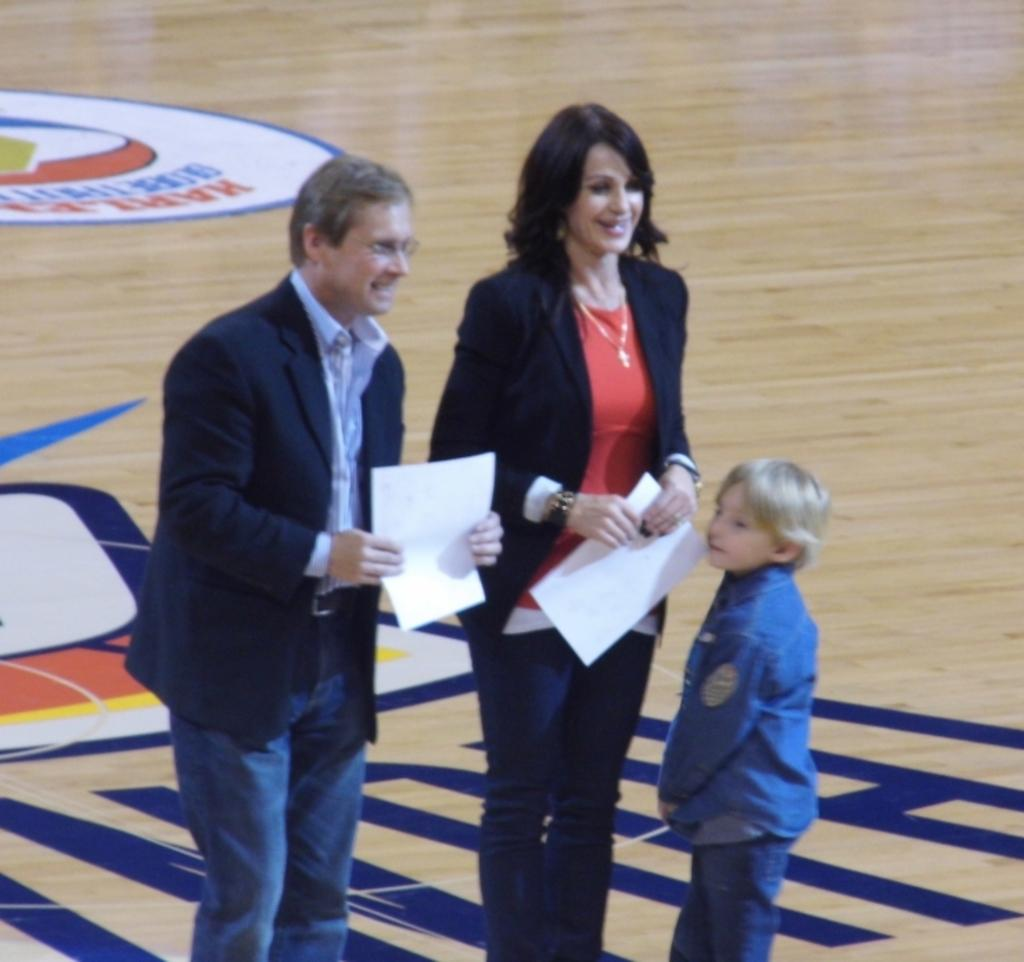How many people are in the image? There are three people in the image: a man, a woman, and a child. What are the man and woman holding in the image? The man and woman are holding papers in the image. What surface are they standing on? They are all standing on the floor. What type of nest can be seen in the image? There is no nest present in the image. What activity are the man and woman participating in together? The provided facts do not specify any particular activity they are engaged in. 